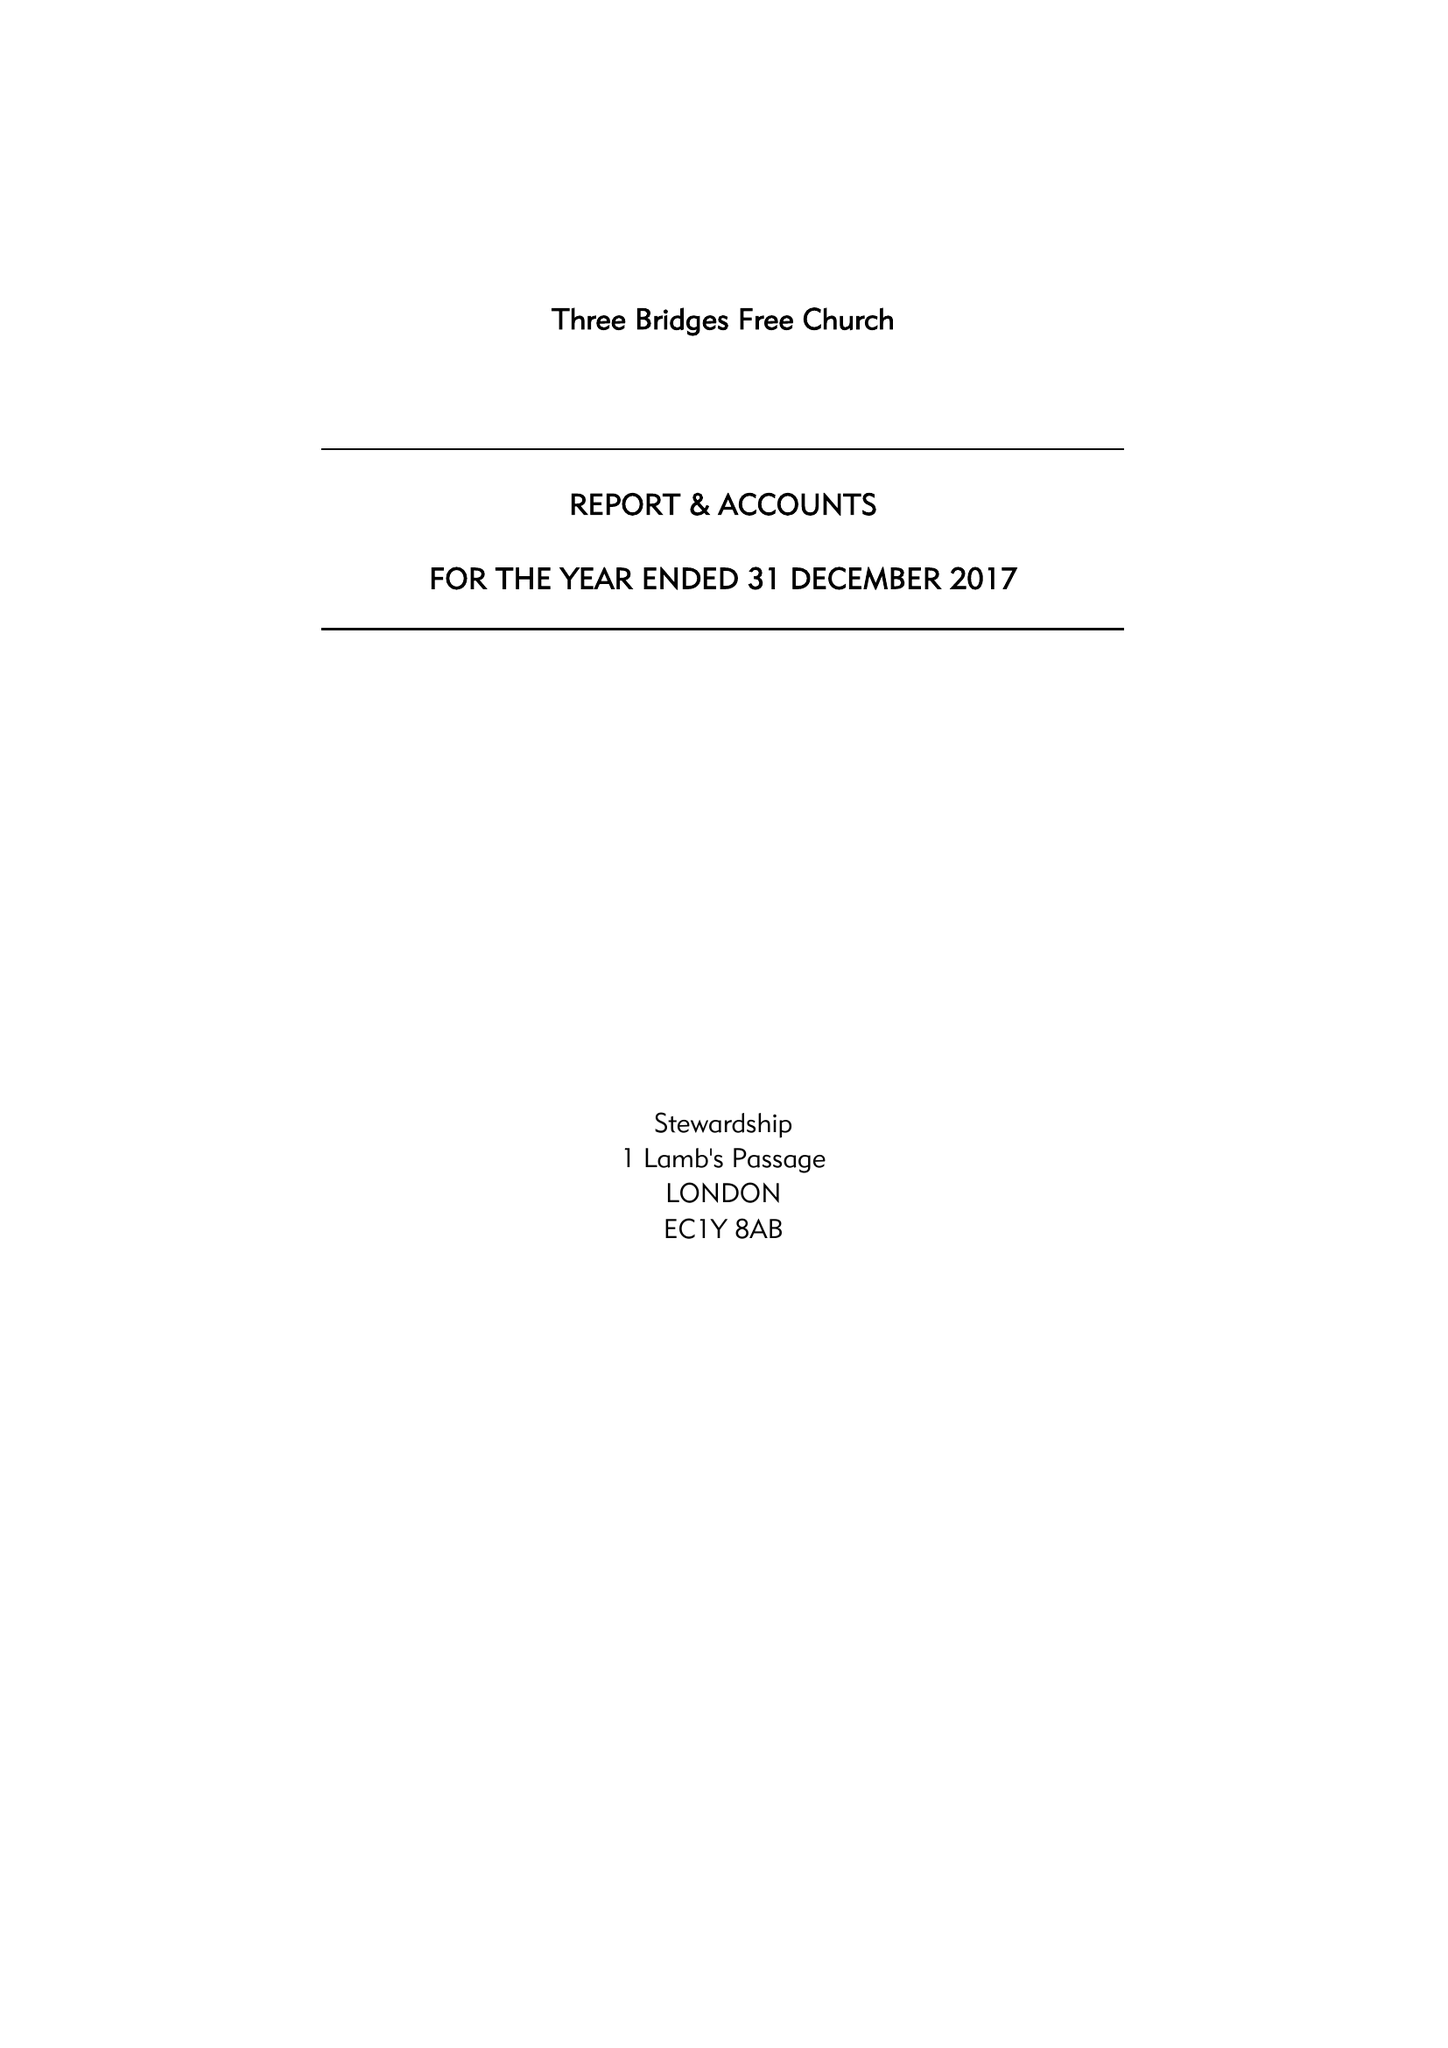What is the value for the address__postcode?
Answer the question using a single word or phrase. RH10 1LS 